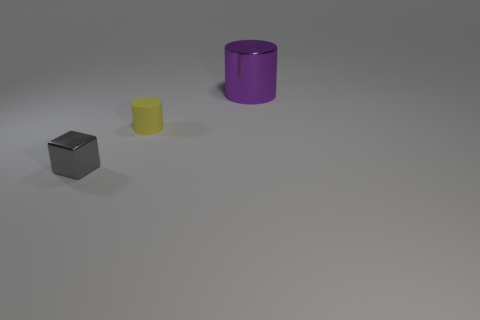Subtract all brown cylinders. Subtract all green cubes. How many cylinders are left? 2 Add 3 gray objects. How many objects exist? 6 Subtract all cubes. How many objects are left? 2 Add 3 small yellow cylinders. How many small yellow cylinders exist? 4 Subtract 1 yellow cylinders. How many objects are left? 2 Subtract all large brown rubber cylinders. Subtract all yellow rubber cylinders. How many objects are left? 2 Add 1 metal things. How many metal things are left? 3 